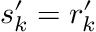<formula> <loc_0><loc_0><loc_500><loc_500>s _ { k } ^ { \prime } = r _ { k } ^ { \prime }</formula> 